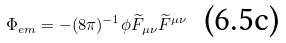Convert formula to latex. <formula><loc_0><loc_0><loc_500><loc_500>\ \Phi _ { e m } = - ( 8 \pi ) ^ { - 1 } \phi \widetilde { F } _ { \mu \nu } \widetilde { F } ^ { \mu \nu } \text { \ (6.5c)}</formula> 